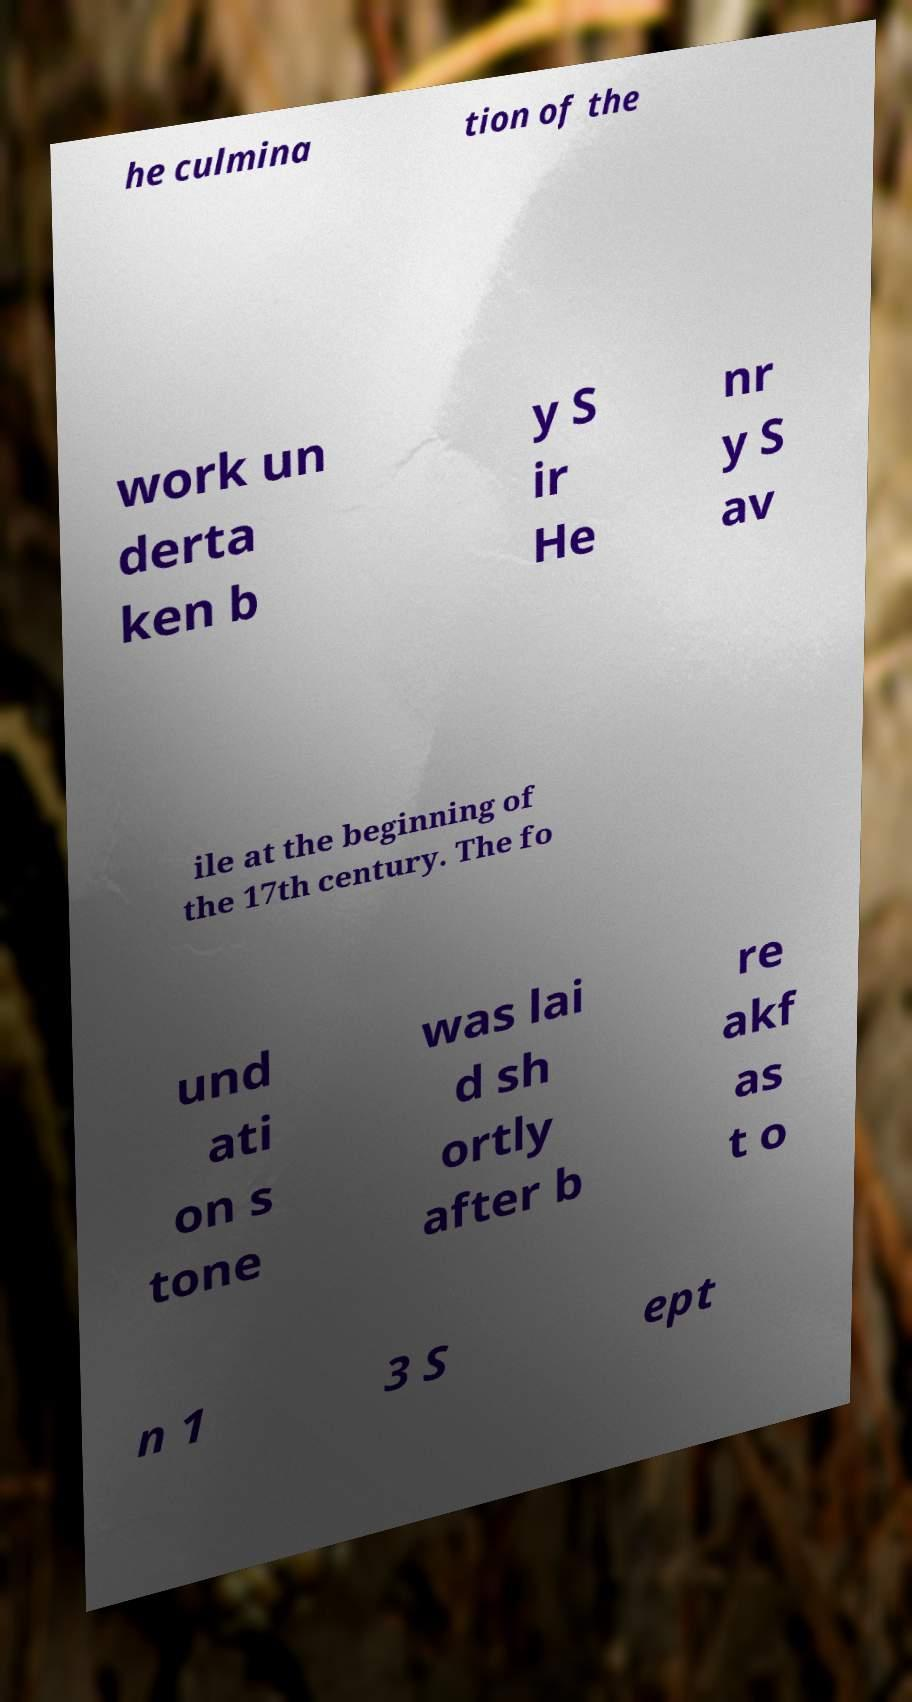Could you extract and type out the text from this image? he culmina tion of the work un derta ken b y S ir He nr y S av ile at the beginning of the 17th century. The fo und ati on s tone was lai d sh ortly after b re akf as t o n 1 3 S ept 